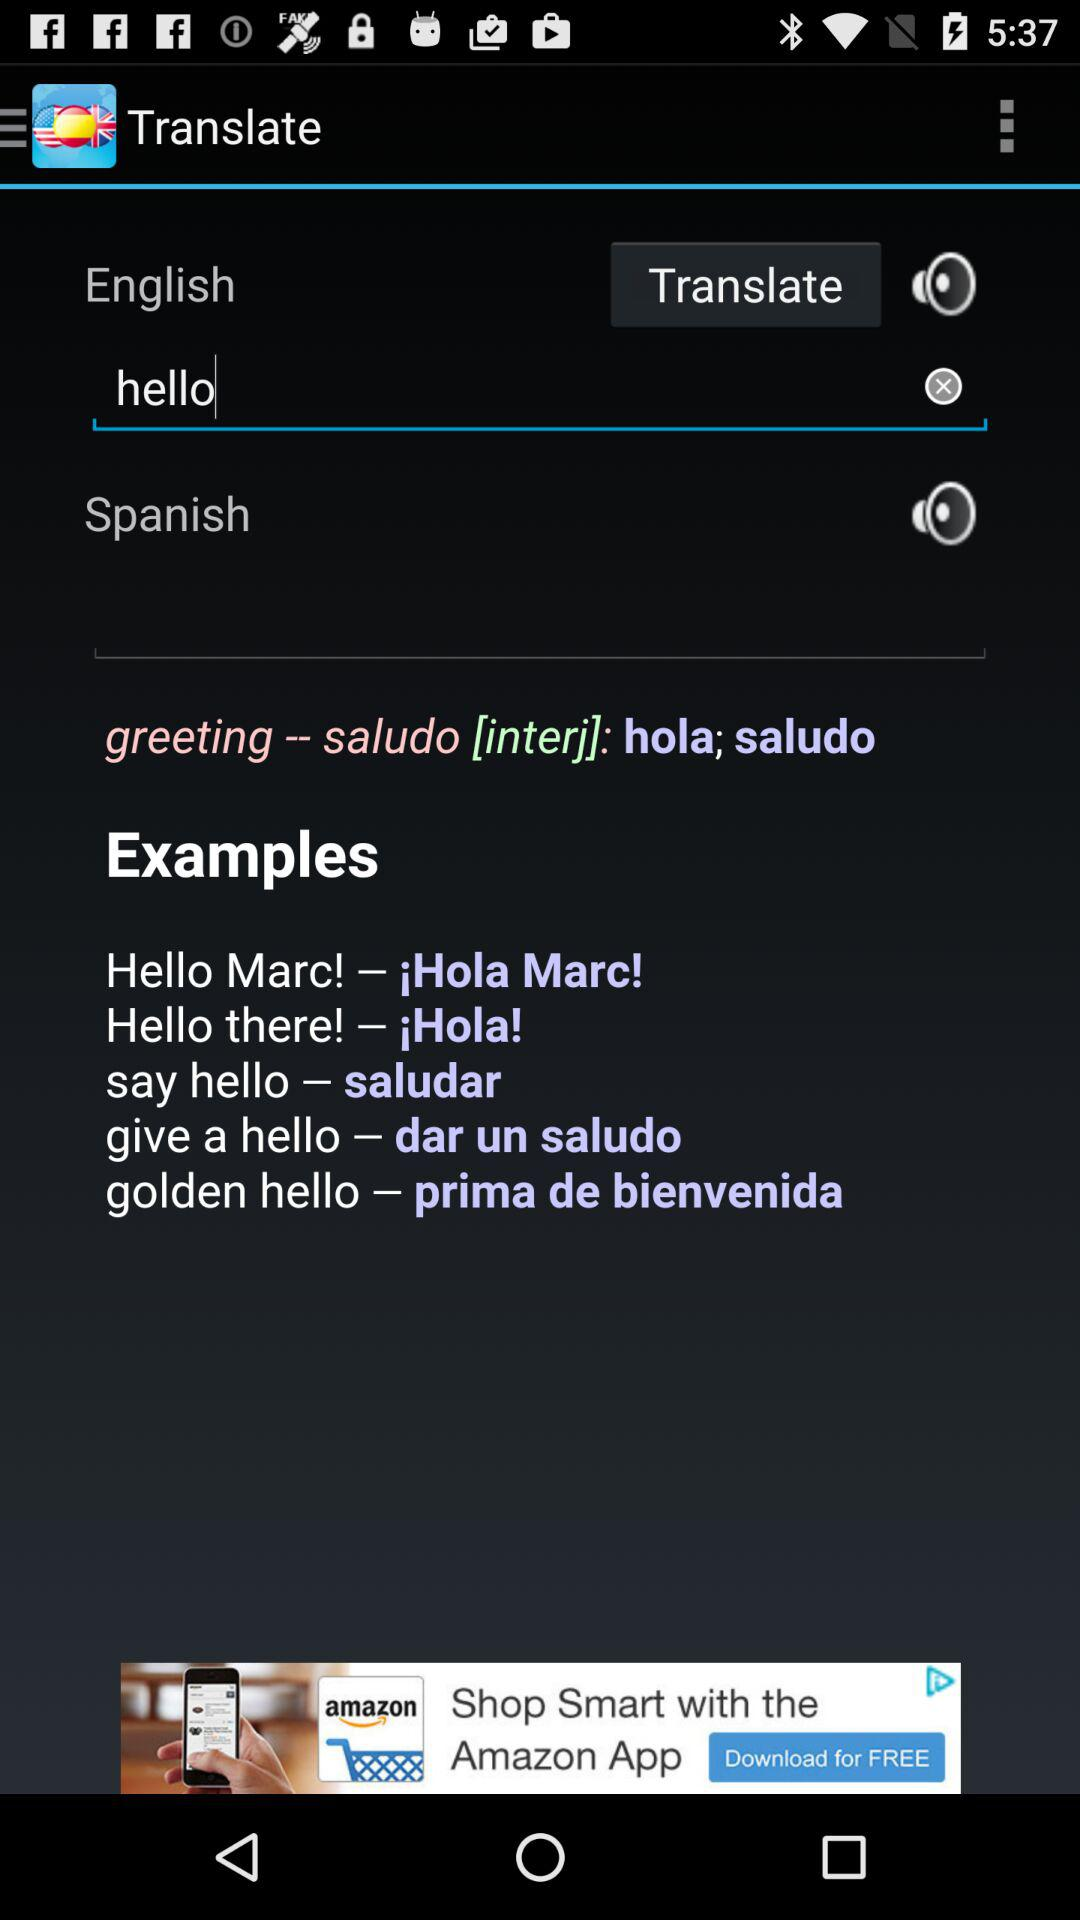In which language is the English language translated? It is translated into the Spanish language. 